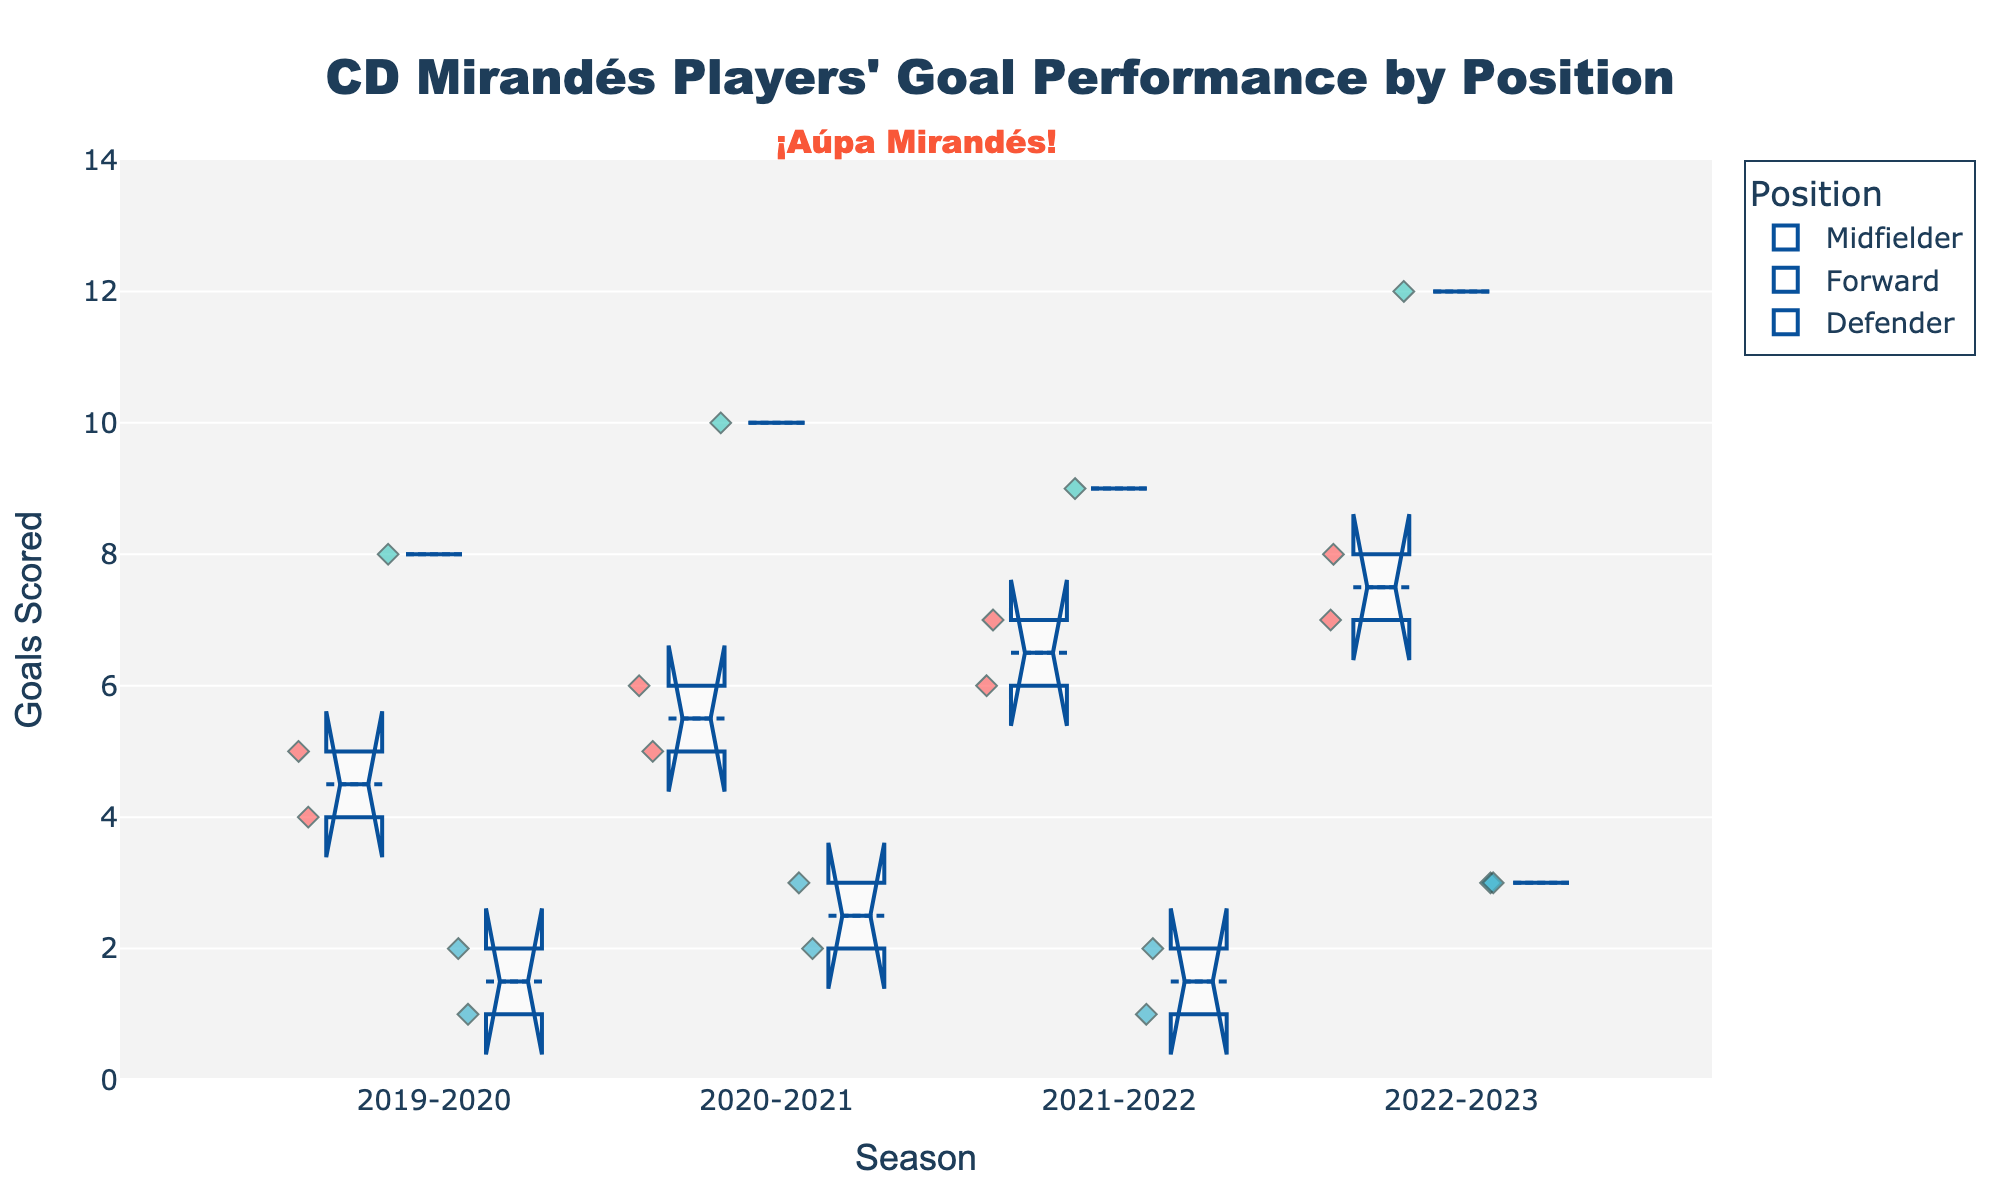What is the title of the figure? The title is usually prominently displayed at the top center of the figure.
Answer: "CD Mirandés Players' Goal Performance by Position" What axis is the "Season" labeled on? The "Season" label is usually represented on the horizontal axis in most plots.
Answer: x-axis What is the color used to represent Midfielders? The colors for different positions are indicated in the legend. Look for Midfielder and identify its color.
Answer: Red Which season had the highest median goals for Forwards? Identify the notched part (median) of the box plot for each season for Forwards; the season with the notch at the highest y-value has the highest median.
Answer: 2022-2023 How many goals did Matheus Aias score in the 2020-2021 season? Find the relevant data points for the 2020-2021 season. The goal value can be read directly off the plot.
Answer: 10 Which position shows the most variation in goals across all seasons? Positions with longer boxes and wider notches or which scatter points significantly have more variation in goals. Compare the boxes visually.
Answer: Forwards What is the range of goals scored by Defenders in the 2020-2021 season? Identify the top and bottom of the whiskers for Defenders in 2020-2021 and subtract the smallest value from the largest.
Answer: 2 goals (3 - 1) How did Alvaro Rey's goal performance change from the 2019-2020 season to the 2022-2023 season? Track the median line for Alvaro Rey across the seasons and compare the changes from 2019-2020 to 2022-2023.
Answer: Increased from 5 to 8 Which position consistently had the lowest median goals over the seasons? Look at the median (notched part) of the boxes for each position and see which is consistently lower.
Answer: Defenders Between which two consecutive seasons did Antonio Sanchez have the largest increase in goals scored? Identify the median or data points for Antonio Sanchez and calculate the difference between goals from one season to the next, identifying the largest increase.
Answer: 2021-2022 to 2022-2023 